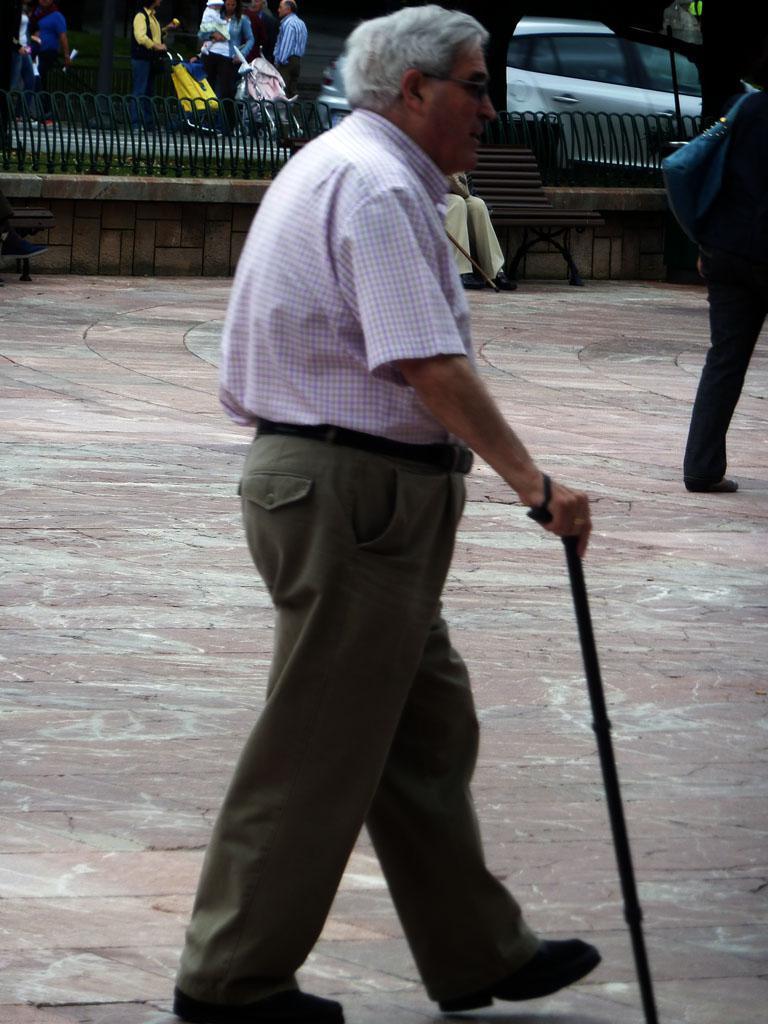In one or two sentences, can you explain what this image depicts? This picture is clicked outside. In the center there is a person wearing shirt, holding a stick and walking on the ground and we can see a person sitting on the bench and a person walking on the ground. In the background there is a vehicle and group of persons seems to be standing on the ground. 